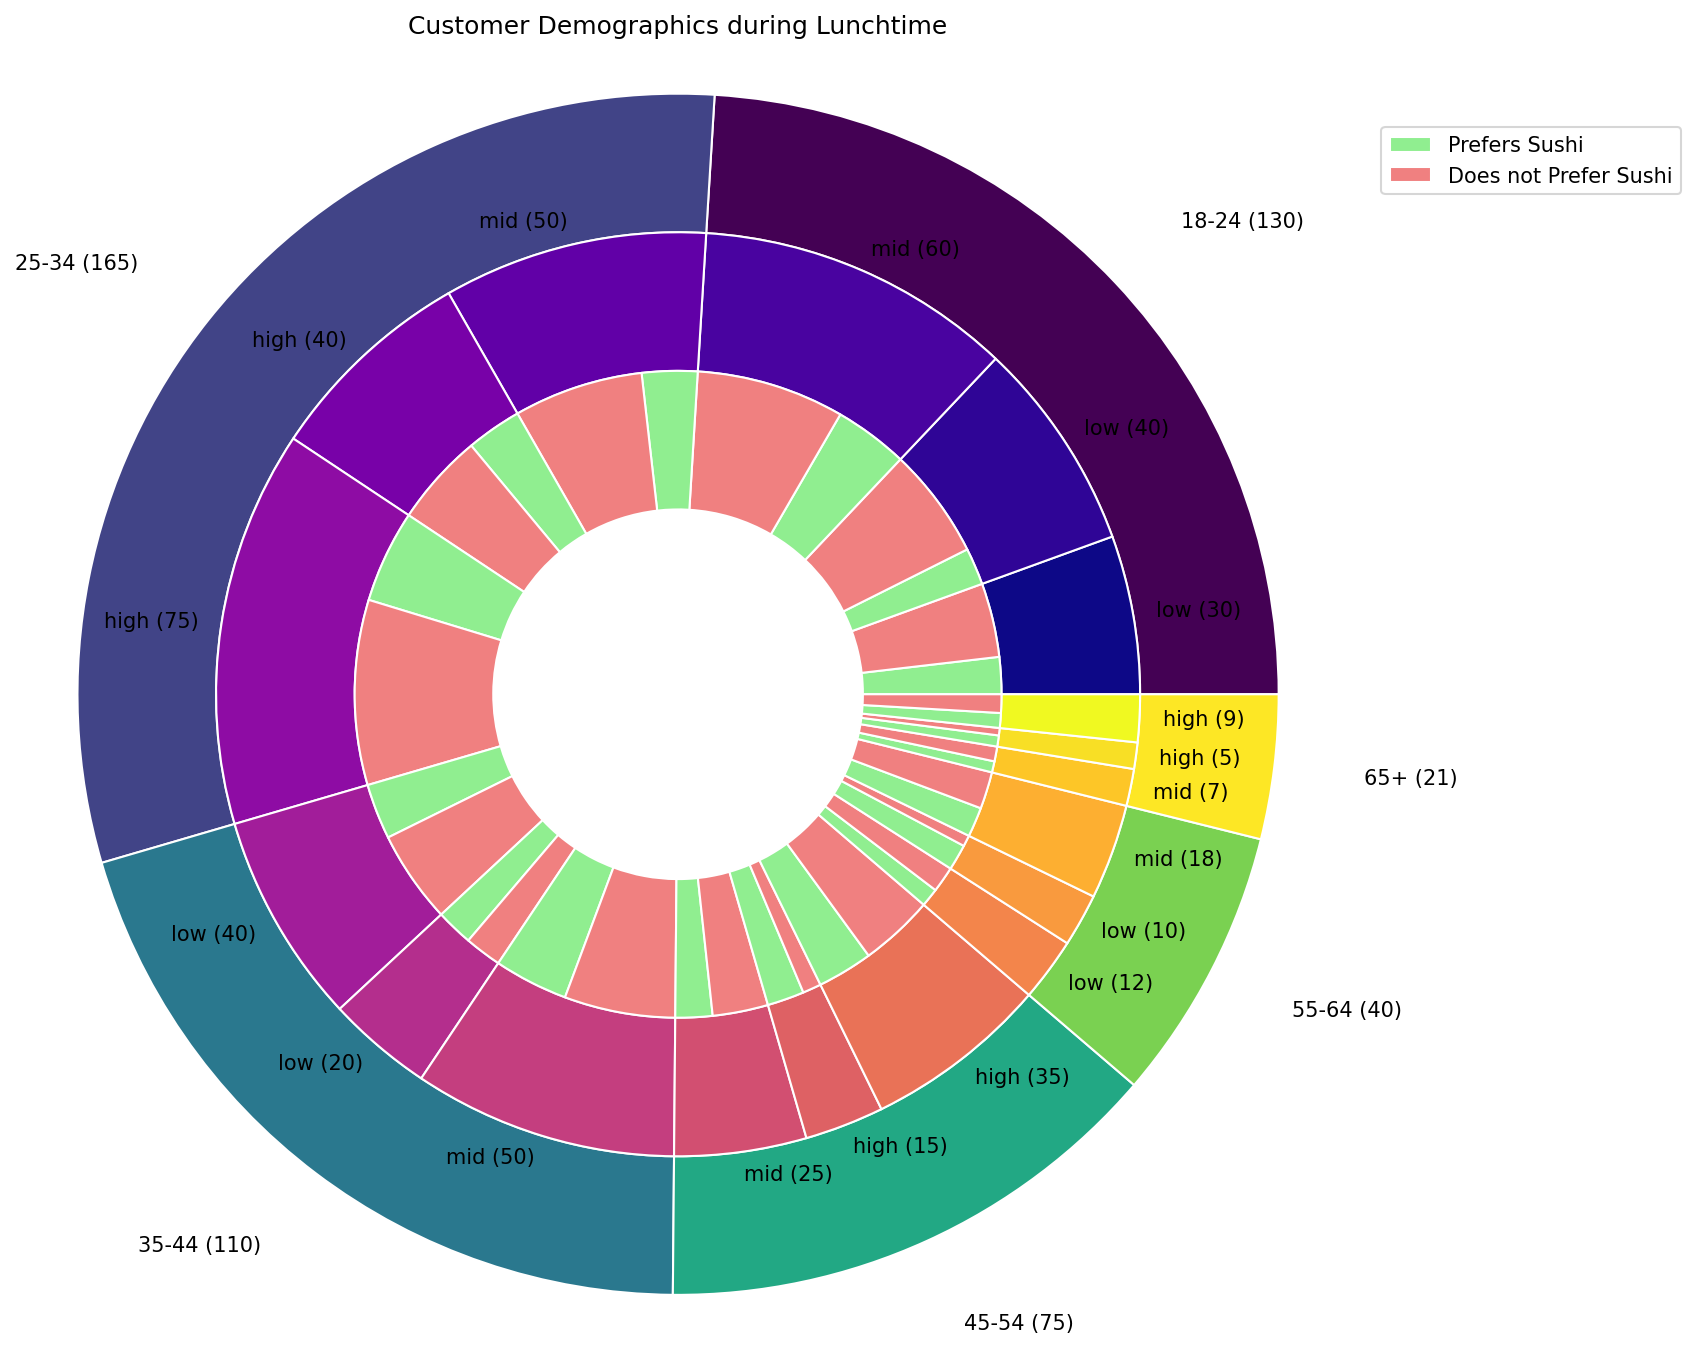What proportion of the 25-34 age group has a high income level as opposed to a low income level? To determine the proportion, refer to the middle pie that shows income levels within the 25-34 age group. Sum the counts for high income (35 + 15 = 50) and low income (25 + 15 = 40). The proportion of high to low income is \( \frac{50}{40} = 1.25 \).
Answer: 1.25 Which age group has the highest number of customers preferring sushi? Look at the slices of the outer pie chart (age group) labeled with numbers for easy identification. Find the largest slice among them and focus on the inner segments for "yes" preferences. The 25-34 age group, with **110** customers, has the highest number preferring sushi.
Answer: 25-34 Among the customers with a middle income level, do more in the 35-44 age group prefer sushi, or do more in the 45-54 age group not prefer sushi? First, identify the middle-income segments for the 35-44 (30 prefer sushi, 20 do not prefer) and 45-54 (20 prefer sushi, 15 do not prefer) age groups. Compare the numbers, 30 (35-44 prefer sushi) vs. 15 (45-54 do not prefer sushi).
Answer: 35-44 prefer sushi In which age group do customers with low income form the largest segment? Check the middle pies representing the income distribution among age groups and find the largest segment for low income. The 18-24 age group has the largest low-income segment (30 + 10 = 40).
Answer: 18-24 What percentage of the total customers in the 55-64 age group prefers sushi? Identify the inner ring section for the 55-64 age group and calculate the sum of individuals who prefer (3 + 10 + 7 = 20) and total individuals within 55-64 (3+7+10+8+7+5 = 40). Then, compute the percentage \(\frac{20}{40} \times 100 = 50\%\).
Answer: 50% Do more customers aged 65+ with a high-income level prefer sushi or not? Examine the high-income slice in the 65+ age group and count those preferring versus not preferring sushi. For high-income, 4 prefer, and 3 do not prefer sushi. Compare the numbers.
Answer: Prefer sushi Is there a greater difference in sushi preferences within the 18-24 age group in low or mid-income levels? Calculate the difference in counts for 'yes' and 'no' within low (30-10=20) and mid-income (40-20=20) levels. Both income levels have the same difference.
Answer: Same Which income level forms the smallest segment within the 45-54 age group? Assess the segments in the middle pie chart with respective sizes. The low-income level (5 + 10 = 15) is the smallest segment within the 45-54 age group.
Answer: Low 